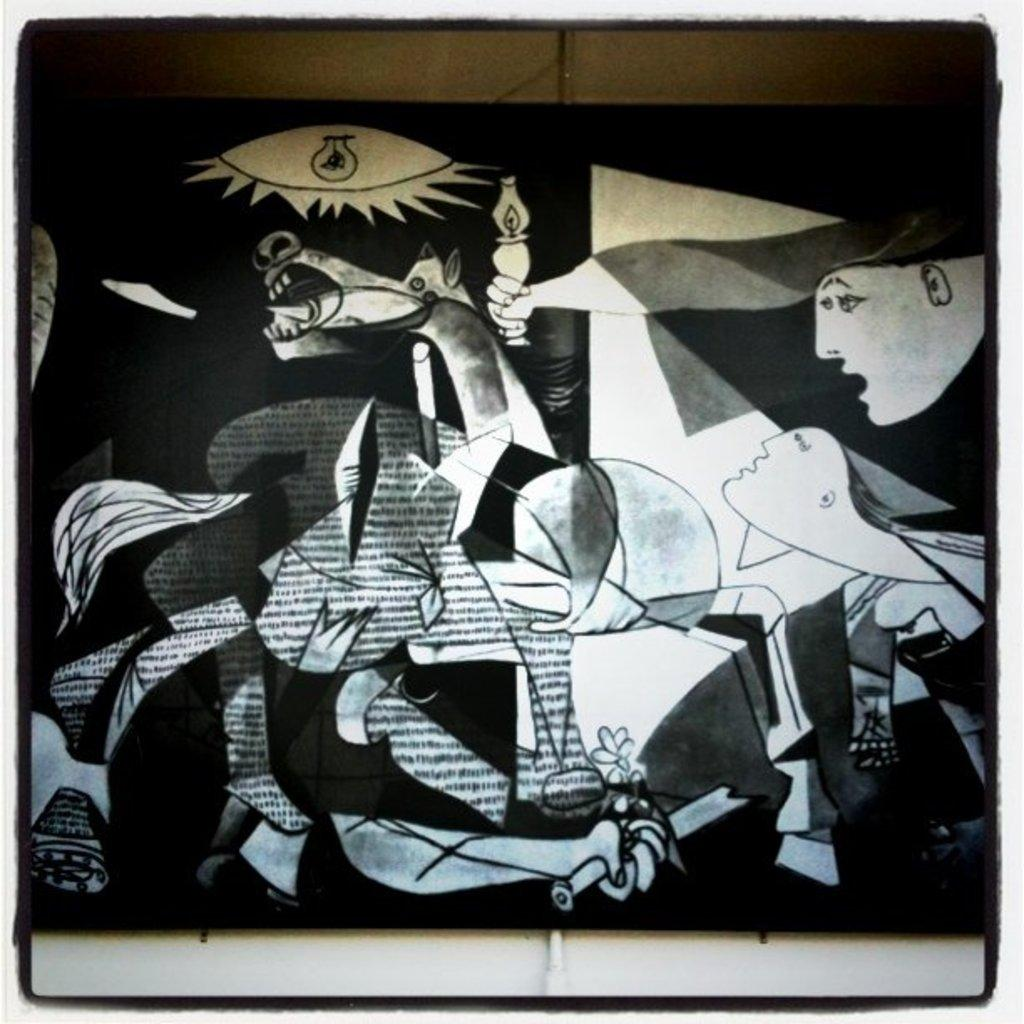What is the main subject of the image? There is a painting in the image. Where is the painting located? The painting is placed on a wall. What else can be seen at the bottom of the image? There is a pipe visible at the bottom of the image. What advice does the painting give in the image? The painting does not give any advice in the image, as it is an inanimate object and cannot speak or provide advice. 